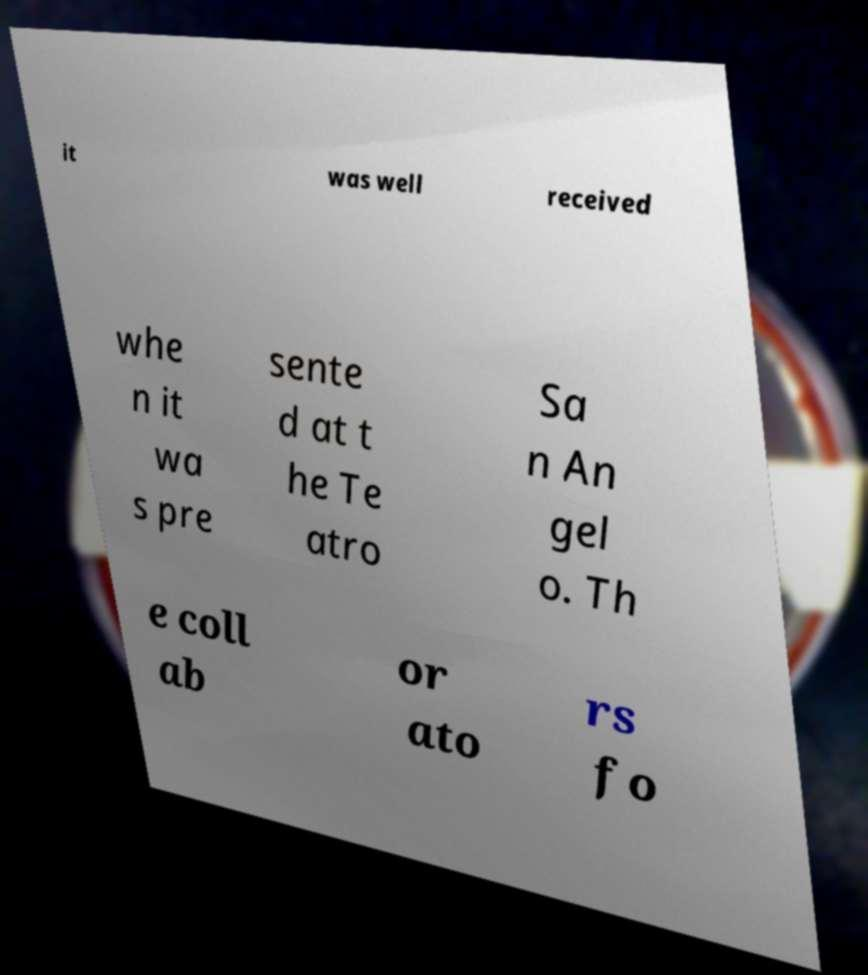Can you accurately transcribe the text from the provided image for me? it was well received whe n it wa s pre sente d at t he Te atro Sa n An gel o. Th e coll ab or ato rs fo 